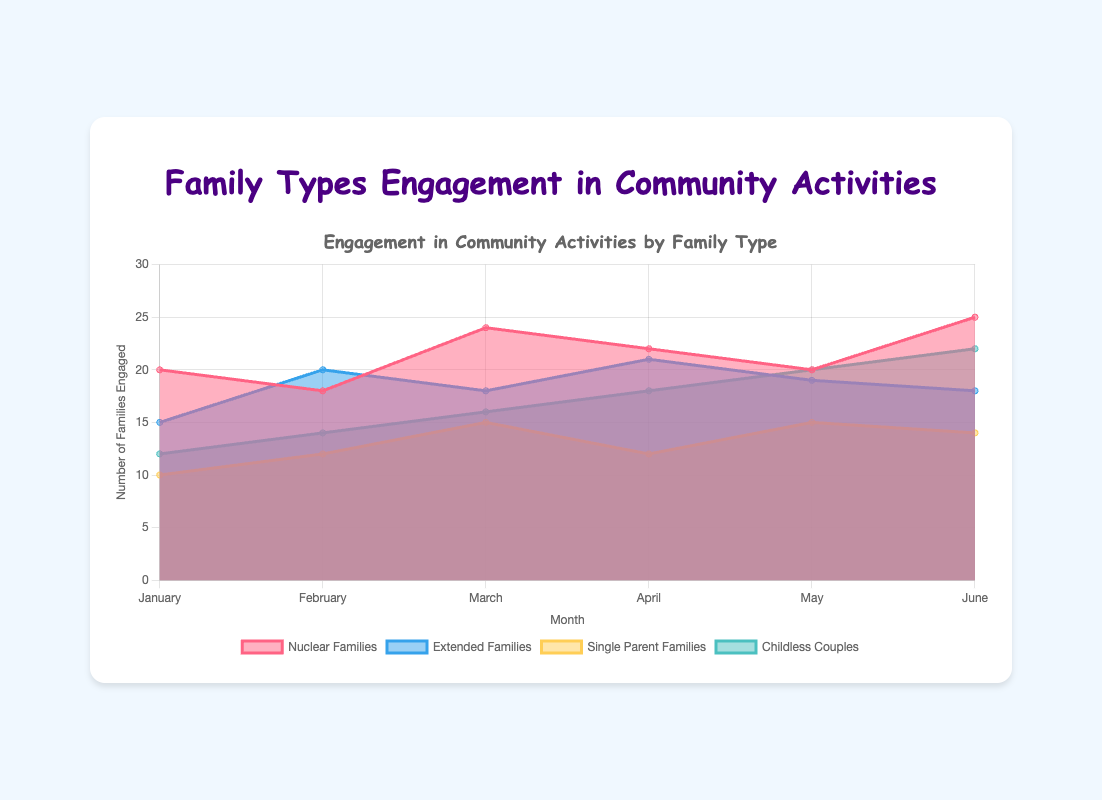How many nuclear families engaged in community activities in May? According to the chart, locate the data point for "Nuclear Families" in May. The count reads 20.
Answer: 20 Which month had the highest number of childless couples engaging in community activities? Look for the peak in the "Childless Couples" dataset. In June, the count hits the highest at 22.
Answer: June What is the combined total of single parent families engaged in community activities for January and March? Add the values for "Single Parent Families" in January (10) and March (15). The combined total is 25.
Answer: 25 Is the average engagement of extended families in community activities higher in February or April? Calculate the average:  
February: (15 + 20)/2 = 17.5  
April: (21 + 19)/2 = 20  
April has a higher average of 20.
Answer: April In which month did nuclear families see a drop in community engagement compared to the previous month? Look for a month where the "Nuclear Families" line drops compared to the prior: From January (20) to February (18), it's a decrease.
Answer: February Which family type had the least engagement in community activities in January? Identify the smallest data point in January: "Single Parent Families" with 10 families.
Answer: Single Parent Families How many more childless couples engaged in community activities in June compared to April? Find the data points: June (22) and April (18). Difference is 22 - 18 = 4.
Answer: 4 What's the total number of families (all types) engaged in community activities in June? Sum all family types in June: 25 + 18 + 14 + 22 = 79.
Answer: 79 